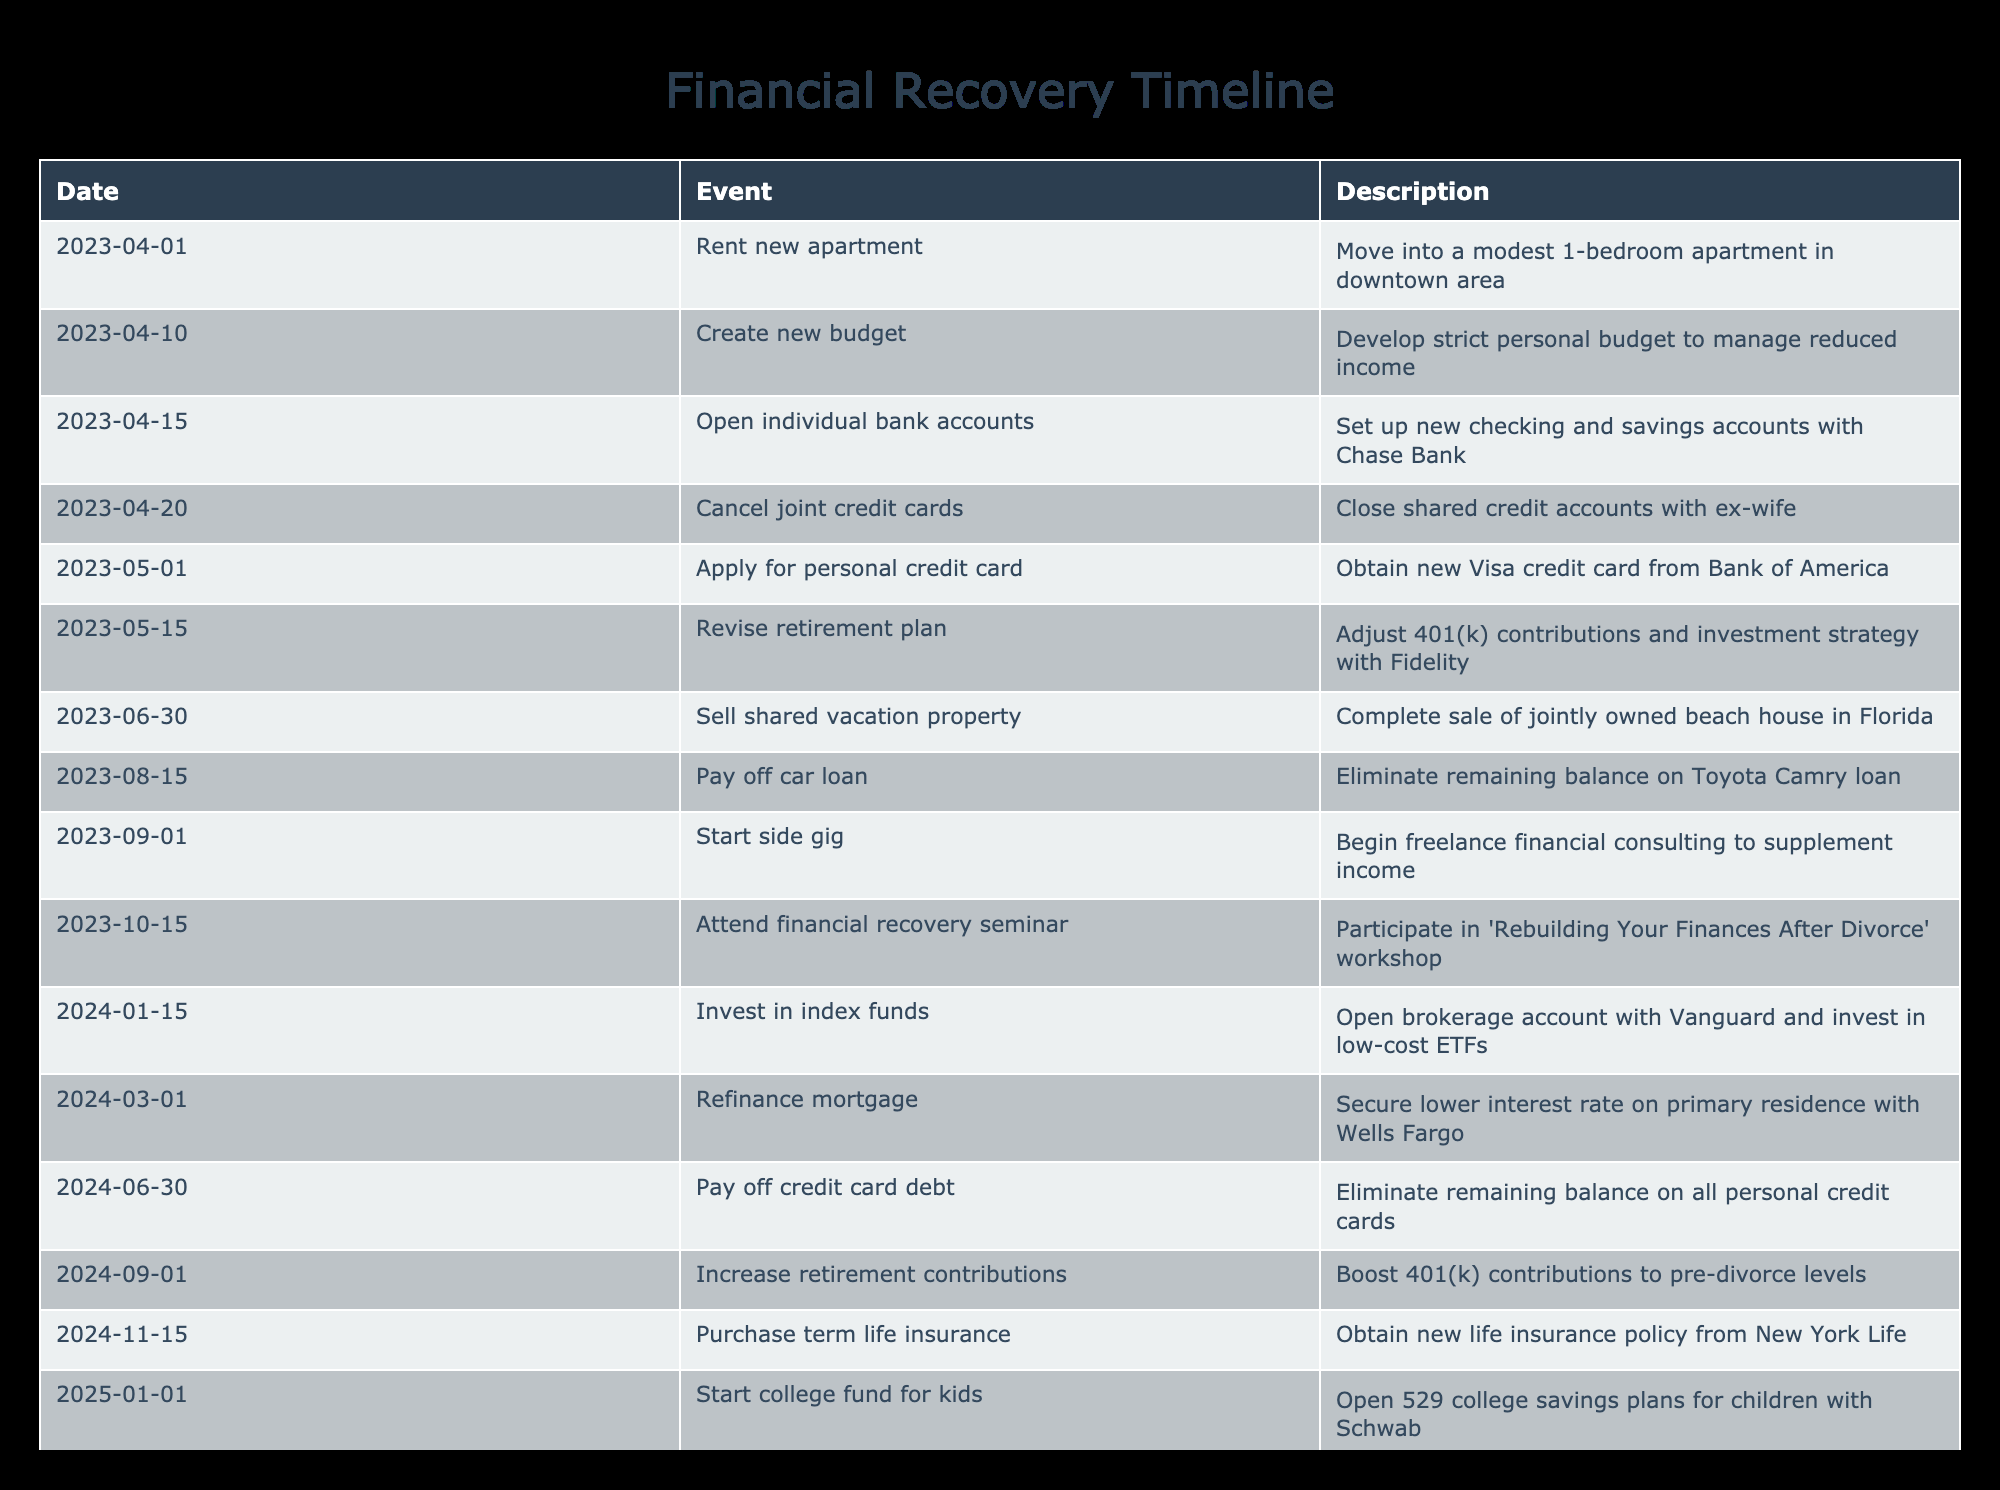What event occurred on April 20, 2023? The table indicates that on April 20, 2023, the individual canceled joint credit cards, which involves closing shared credit accounts with his ex-wife.
Answer: Cancel joint credit cards What is the total number of events listed in the timeline? By counting the number of rows in the table, we find there are 16 events present.
Answer: 16 Which event marks the start of personal income supplementation? The timeline shows that the event titled "Start side gig" on September 1, 2023, marks the beginning of freelance financial consulting to supplement income.
Answer: Start side gig Is it true that the individual achieved financial recovery by December 31, 2025? Since the last event listed is about planning for early retirement, which indicates ongoing financial recovery efforts, the statement that he achieved financial recovery by that date can be considered true, as this planning shows a developed strategy for further improvement.
Answer: Yes What is the difference in months between the event of "Pay off credit card debt" and "Create new budget"? The event "Pay off credit card debt" occurs on June 30, 2024, while "Create new budget" is on April 10, 2023. The difference is 15 months from April 2023 to June 2024.
Answer: 15 months Which financial institution was involved in the refinancing of the mortgage? According to the table, the refinancing of the mortgage took place with Wells Fargo on March 1, 2024.
Answer: Wells Fargo How many months passed from "Attend financial recovery seminar" to "Invest in index funds"? The seminar is listed on October 15, 2023, and the investment event occurs on January 15, 2024. Therefore, there are 3 months between these events.
Answer: 3 months What was the purpose of opening individual bank accounts as listed in the events? The table describes that opening individual bank accounts was to set up new checking and savings accounts with Chase Bank, facilitating personal financial management after the divorce.
Answer: Set up new checking and savings accounts What event indicates a significant change in retirement planning, and when did it occur? The event that indicates a significant change in retirement planning is "Revise retirement plan," which took place on May 15, 2023, focusing on adjusting 401(k) contributions and investment strategy.
Answer: Revise retirement plan on May 15, 2023 